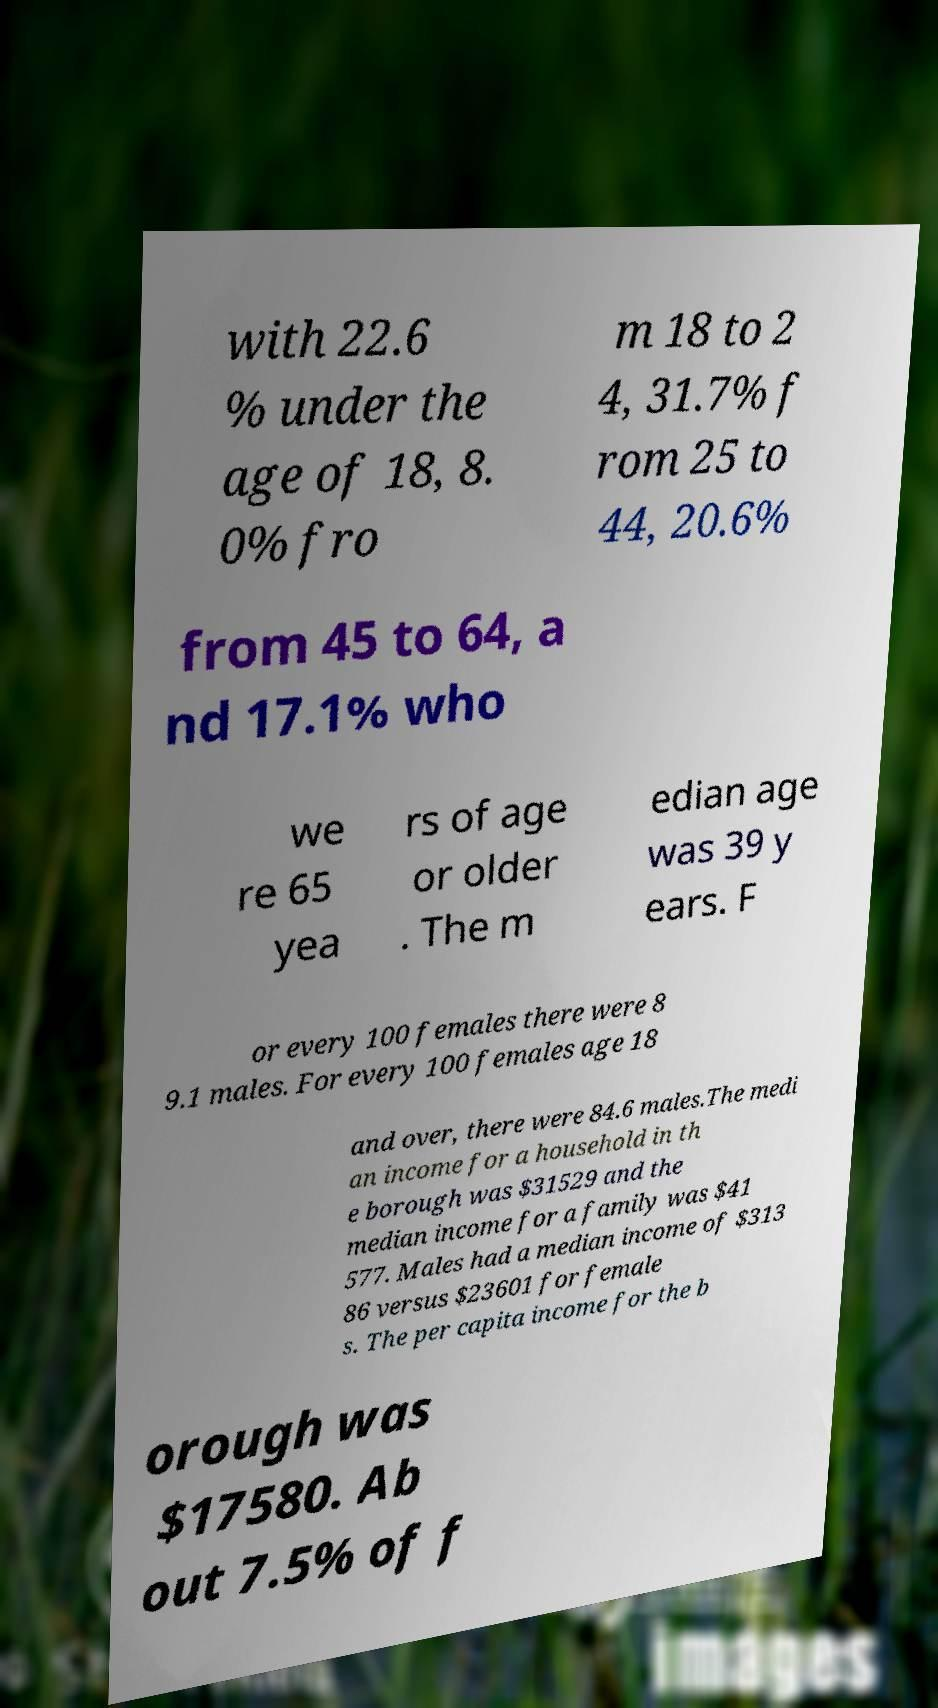Please identify and transcribe the text found in this image. with 22.6 % under the age of 18, 8. 0% fro m 18 to 2 4, 31.7% f rom 25 to 44, 20.6% from 45 to 64, a nd 17.1% who we re 65 yea rs of age or older . The m edian age was 39 y ears. F or every 100 females there were 8 9.1 males. For every 100 females age 18 and over, there were 84.6 males.The medi an income for a household in th e borough was $31529 and the median income for a family was $41 577. Males had a median income of $313 86 versus $23601 for female s. The per capita income for the b orough was $17580. Ab out 7.5% of f 